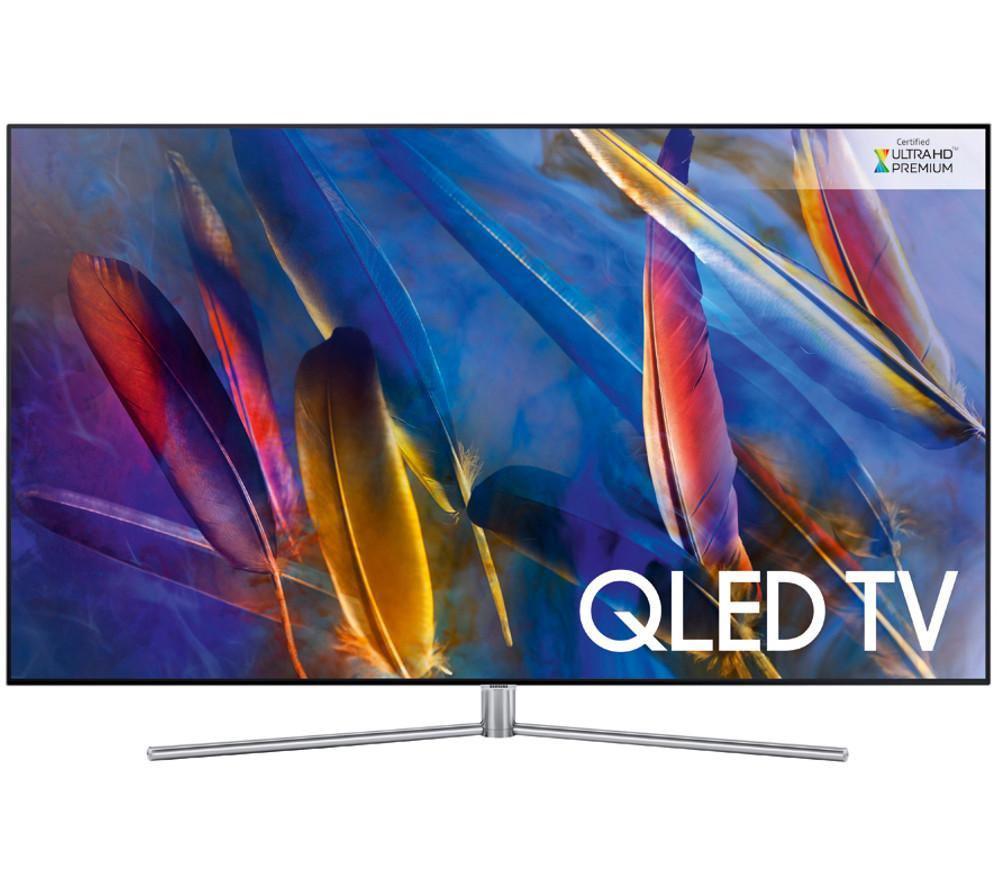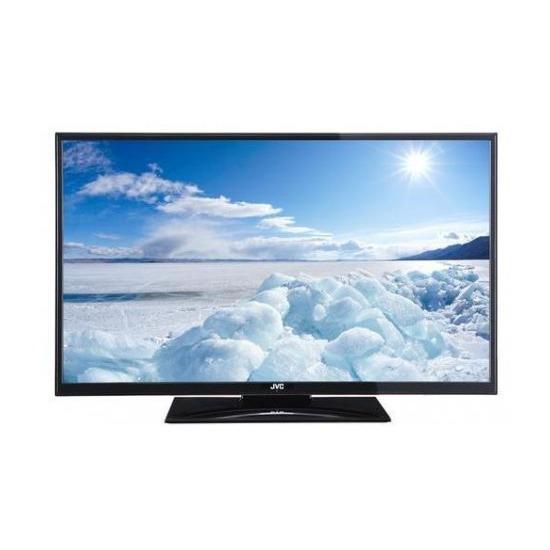The first image is the image on the left, the second image is the image on the right. For the images shown, is this caption "Atleast one tv has an image of something alive." true? Answer yes or no. No. 